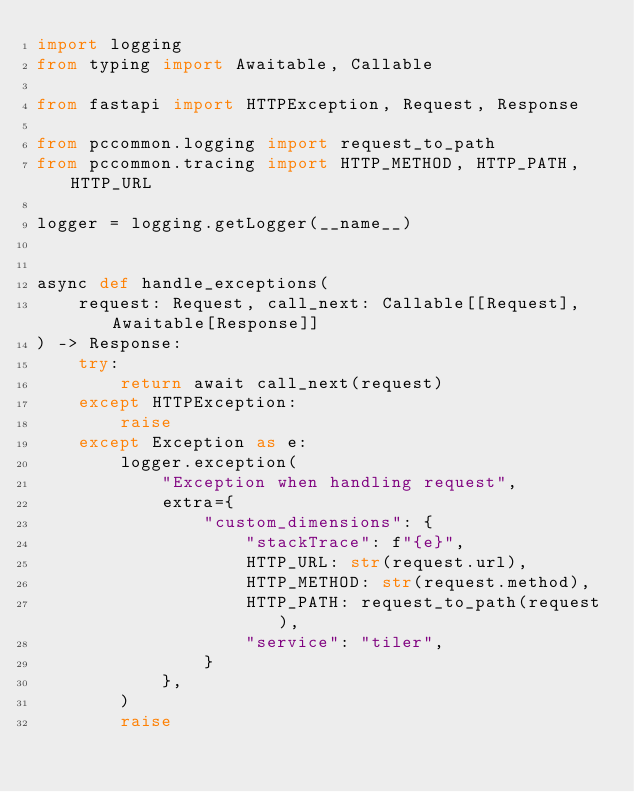Convert code to text. <code><loc_0><loc_0><loc_500><loc_500><_Python_>import logging
from typing import Awaitable, Callable

from fastapi import HTTPException, Request, Response

from pccommon.logging import request_to_path
from pccommon.tracing import HTTP_METHOD, HTTP_PATH, HTTP_URL

logger = logging.getLogger(__name__)


async def handle_exceptions(
    request: Request, call_next: Callable[[Request], Awaitable[Response]]
) -> Response:
    try:
        return await call_next(request)
    except HTTPException:
        raise
    except Exception as e:
        logger.exception(
            "Exception when handling request",
            extra={
                "custom_dimensions": {
                    "stackTrace": f"{e}",
                    HTTP_URL: str(request.url),
                    HTTP_METHOD: str(request.method),
                    HTTP_PATH: request_to_path(request),
                    "service": "tiler",
                }
            },
        )
        raise
</code> 